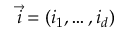Convert formula to latex. <formula><loc_0><loc_0><loc_500><loc_500>\vec { i } = ( i _ { 1 } , \dots , i _ { d } )</formula> 